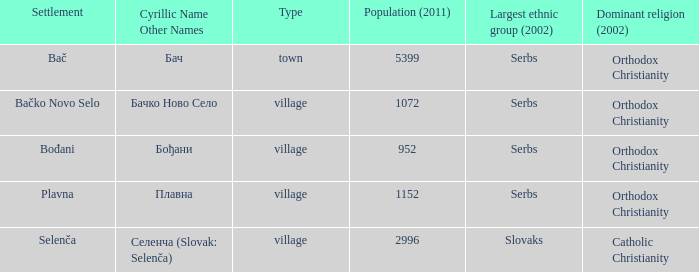Which population number is the smallest on the list? 952.0. 